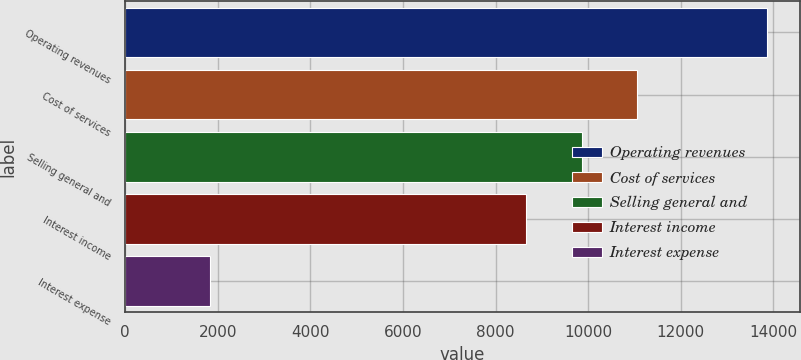<chart> <loc_0><loc_0><loc_500><loc_500><bar_chart><fcel>Operating revenues<fcel>Cost of services<fcel>Selling general and<fcel>Interest income<fcel>Interest expense<nl><fcel>13875<fcel>11062.2<fcel>9858.1<fcel>8654<fcel>1834<nl></chart> 